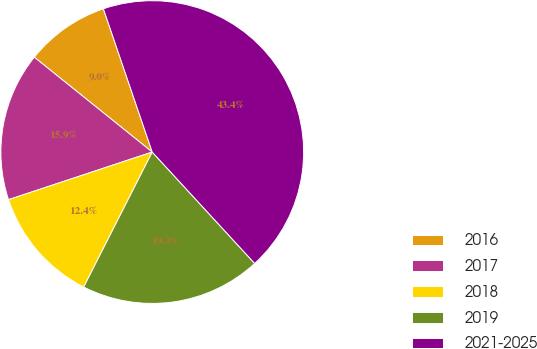<chart> <loc_0><loc_0><loc_500><loc_500><pie_chart><fcel>2016<fcel>2017<fcel>2018<fcel>2019<fcel>2021-2025<nl><fcel>8.99%<fcel>15.87%<fcel>12.43%<fcel>19.31%<fcel>43.39%<nl></chart> 